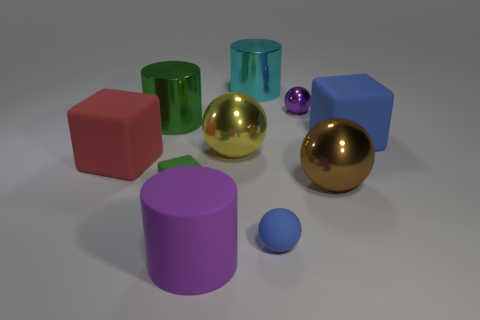Subtract all big cubes. How many cubes are left? 1 Subtract 1 spheres. How many spheres are left? 3 Subtract all red cubes. How many cubes are left? 2 Subtract all green cylinders. Subtract all green spheres. How many cylinders are left? 2 Subtract all purple blocks. How many red spheres are left? 0 Subtract all red rubber objects. Subtract all red matte blocks. How many objects are left? 8 Add 2 big brown metallic things. How many big brown metallic things are left? 3 Add 6 large yellow spheres. How many large yellow spheres exist? 7 Subtract 1 blue balls. How many objects are left? 9 Subtract all blocks. How many objects are left? 7 